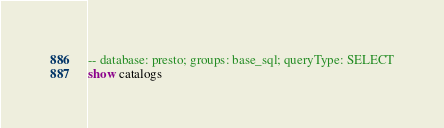<code> <loc_0><loc_0><loc_500><loc_500><_SQL_>-- database: presto; groups: base_sql; queryType: SELECT
show catalogs
</code> 